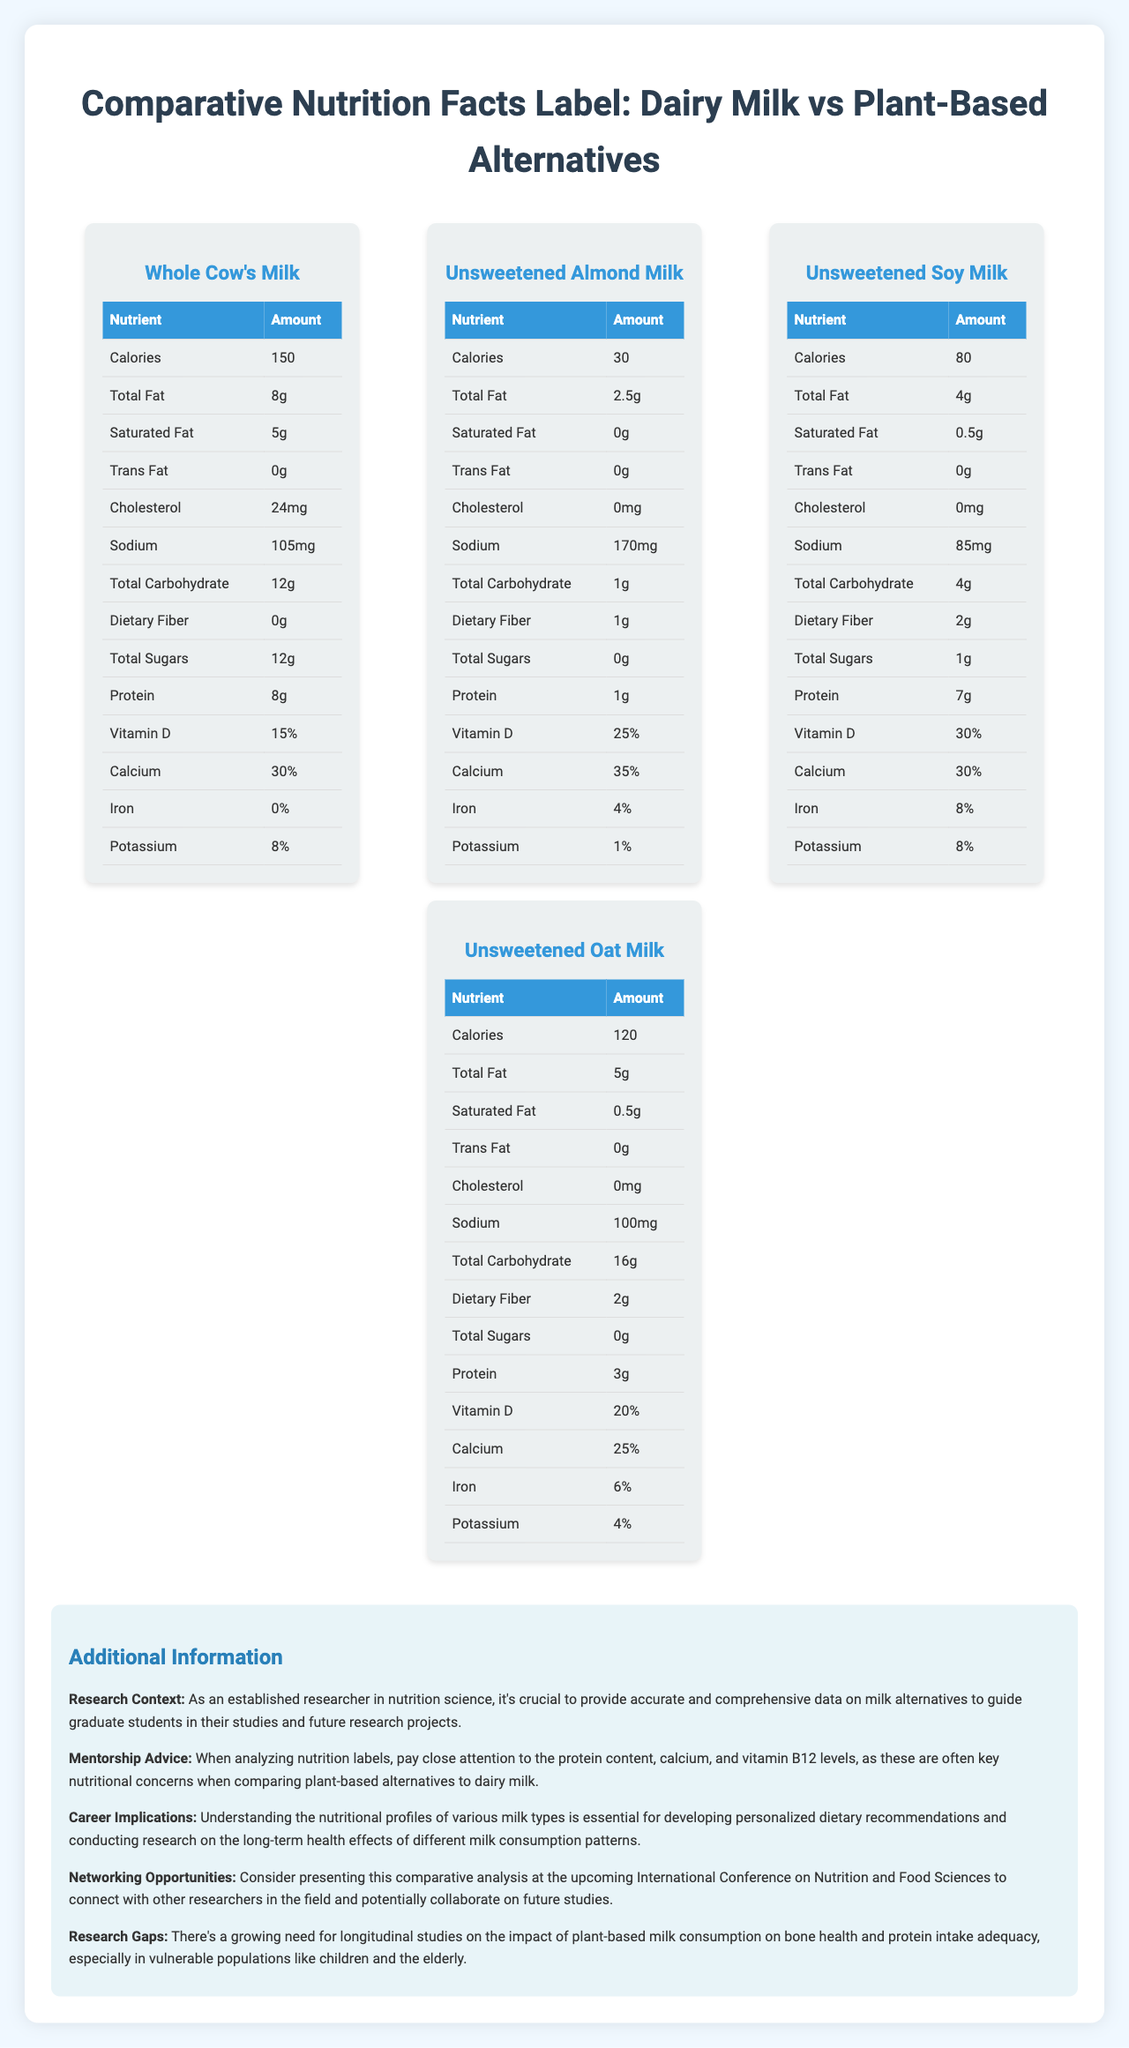what is the serving size for these milk types? The document states that the serving size for all milk types is 240 mL, which is equivalent to 1 cup.
Answer: 240 mL (1 cup) which plant-based milk has the highest protein content? A. Unsweetened Almond Milk B. Unsweetened Soy Milk C. Unsweetened Oat Milk Unsweetened Soy Milk has 7g of protein, which is the highest among the plant-based options listed.
Answer: B how many calories does whole cow's milk have per serving? The document lists that Whole Cow's Milk contains 150 calories per 240 mL (1 cup) serving.
Answer: 150 is there any trans fat in unsweetened almond milk? The nutrition label for Unsweetened Almond Milk indicates that it contains 0g of trans fat.
Answer: No which milk type has the highest vitamin D content? A. Whole Cow's Milk B. Unsweetened Almond Milk C. Unsweetened Soy Milk D. Unsweetened Oat Milk Unsweetened Soy Milk has the highest vitamin D content at 30%.
Answer: C does whole cow's milk contain any dietary fiber? According to the document, Whole Cow's Milk contains 0g of dietary fiber.
Answer: No which milk has the highest percentage of vitamin b12? The document states that Unsweetened Soy Milk has 120% of the daily recommended value for vitamin B12, the highest among the options.
Answer: Unsweetened Soy Milk summarize the main idea of the document. The document aims to provide a comprehensive comparison of dairy and plant-based milk options by showcasing their nutritional profiles. It also offers career advice and research directions for those involved in nutrition science.
Answer: The document compares the nutritional information of Whole Cow's Milk with various plant-based milk alternatives, including Unsweetened Almond Milk, Unsweetened Soy Milk, and Unsweetened Oat Milk. It highlights key nutritional differences such as calories, fat, protein, and various vitamins and minerals, providing additional context and advice for researchers and students in nutrition science. which milk type has the lowest sodium content? A. Whole Cow's Milk B. Unsweetened Almond Milk C. Unsweetened Soy Milk D. Unsweetened Oat Milk Unsweetened Soy Milk has 85mg of sodium per serving, the lowest among the listed milk types.
Answer: C does any milk type listed contain cholesterol? According to the document, Whole Cow's Milk contains 24mg of cholesterol per serving, while plant-based options contain 0mg.
Answer: Yes, Whole Cow's Milk is unsweetened almond milk a good source of calcium? Unsweetened Almond Milk contains 35% of the daily recommended value for calcium, making it a good source.
Answer: Yes what is the main source for the comparison of milk types presented in the document? The document compares milk types based on their nutritional facts labels, listing various nutrients such as calories, fat, protein, vitamins, and minerals.
Answer: Nutritional Facts Labels is there any information on the environmental impact of these milk types? The document does not provide any information on the environmental impact of the different milk types.
Answer: Not enough information what is the dietary fiber content of unsweetened oat milk? The document lists the dietary fiber content for Unsweetened Oat Milk as 2 grams per serving.
Answer: 2 grams 